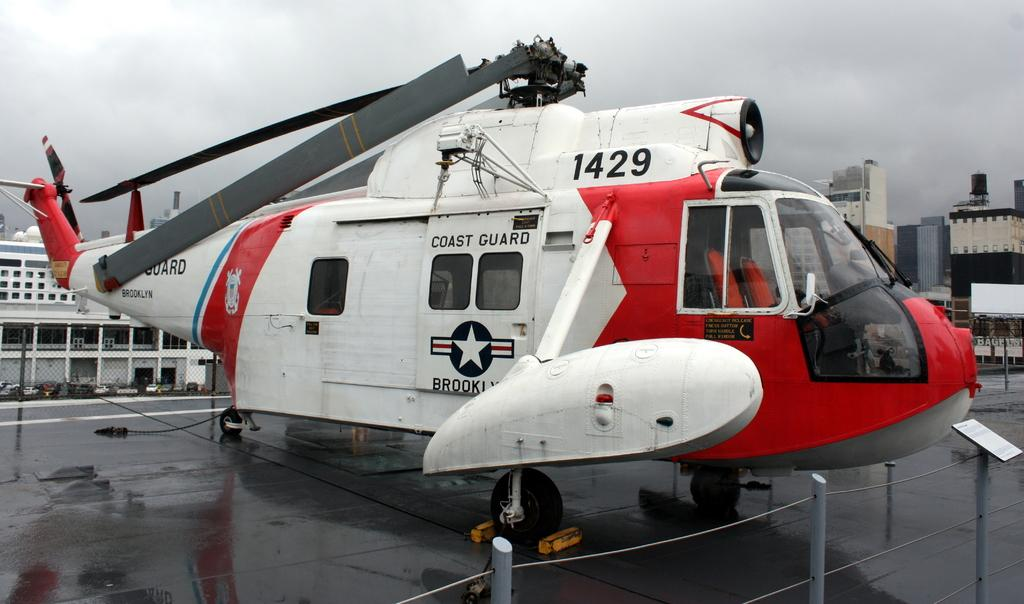What is the main subject of the image? The main subject of the image is a helicopter. What objects are near the helicopter? Iron rods are present in the image, and there is a board in front of the helicopter. What can be seen in the background of the image? There are buildings and vehicles visible in the background of the image. What type of snail can be seen crawling on the board in the image? There is no snail present in the image; the board is in front of the helicopter with no visible snails. 